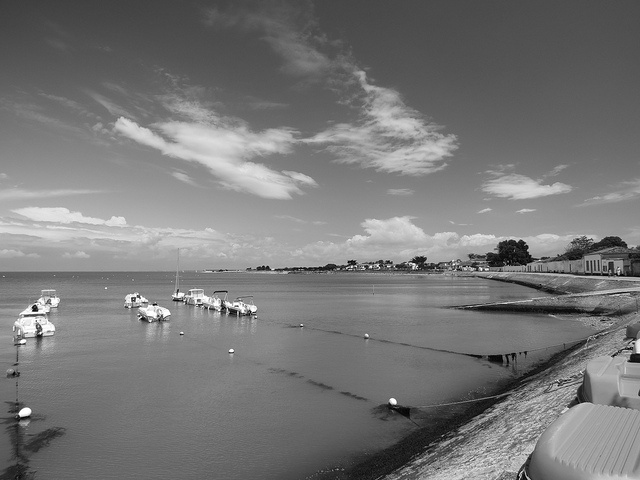Describe the objects in this image and their specific colors. I can see boat in black, white, darkgray, and gray tones, boat in black, white, darkgray, and gray tones, boat in black, darkgray, lightgray, and gray tones, boat in black, darkgray, lightgray, and gray tones, and boat in black, darkgray, lightgray, and gray tones in this image. 